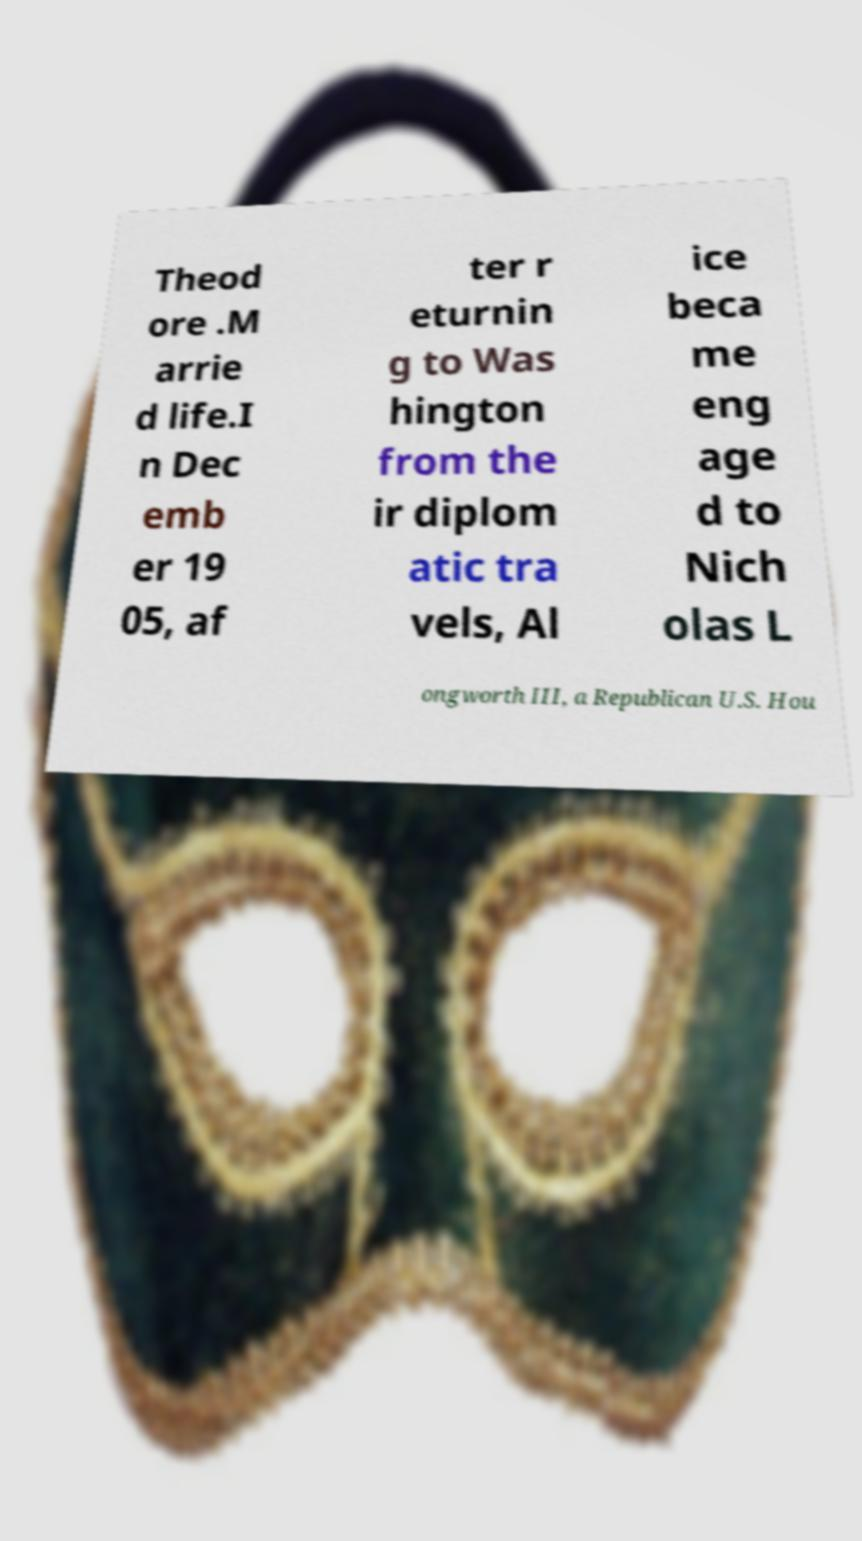For documentation purposes, I need the text within this image transcribed. Could you provide that? Theod ore .M arrie d life.I n Dec emb er 19 05, af ter r eturnin g to Was hington from the ir diplom atic tra vels, Al ice beca me eng age d to Nich olas L ongworth III, a Republican U.S. Hou 